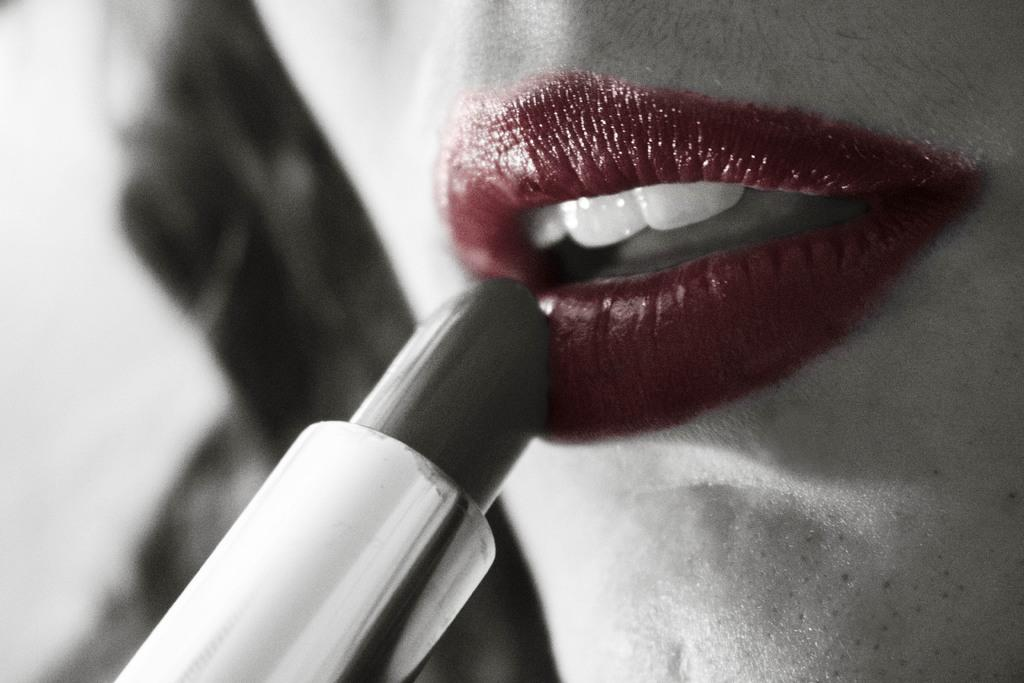What object is located in the foreground of the image? There is a lipstick in the foreground of the image. Where is the lipstick positioned in the image? The lipstick is on the left bottom side of the image. What is the result of using the lipstick in the image? There is a red lip of a woman in the image. What else can be seen about the woman in the image? The woman's hair is visible in the image. What type of plate is visible in the image? There is no plate present in the image. What kind of bushes can be seen in the background of the image? There is no background or bushes present in the image; it focuses on the lipstick and the woman's face. 